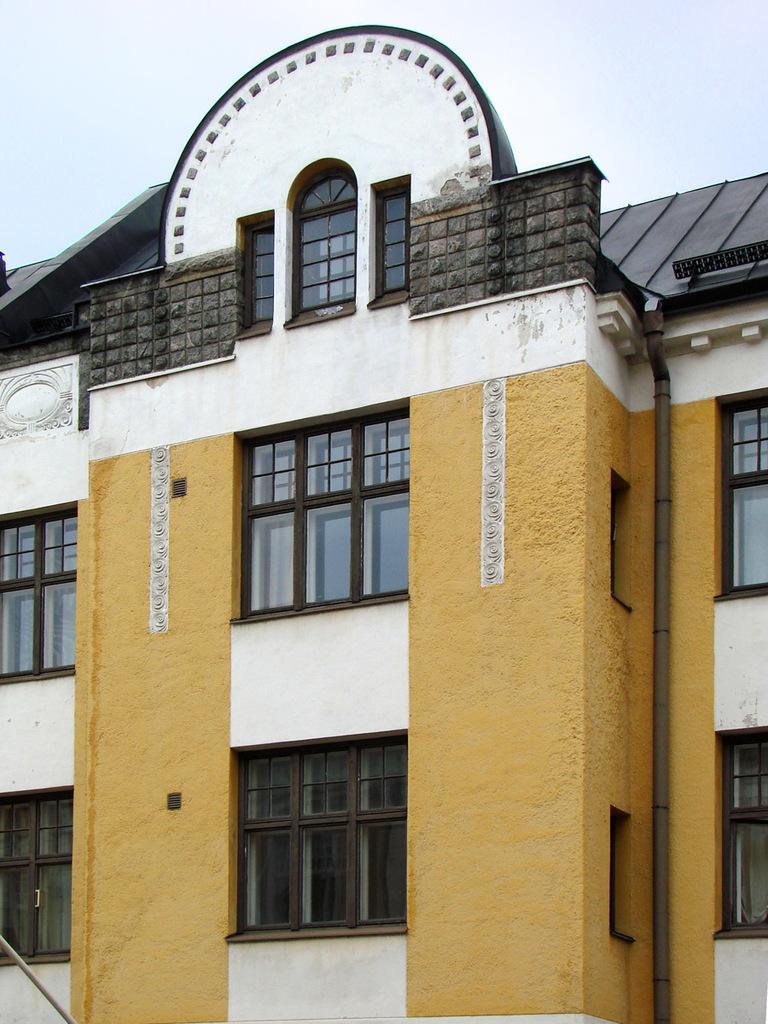In one or two sentences, can you explain what this image depicts? In this image at front there is a building and at the background there is sky. 